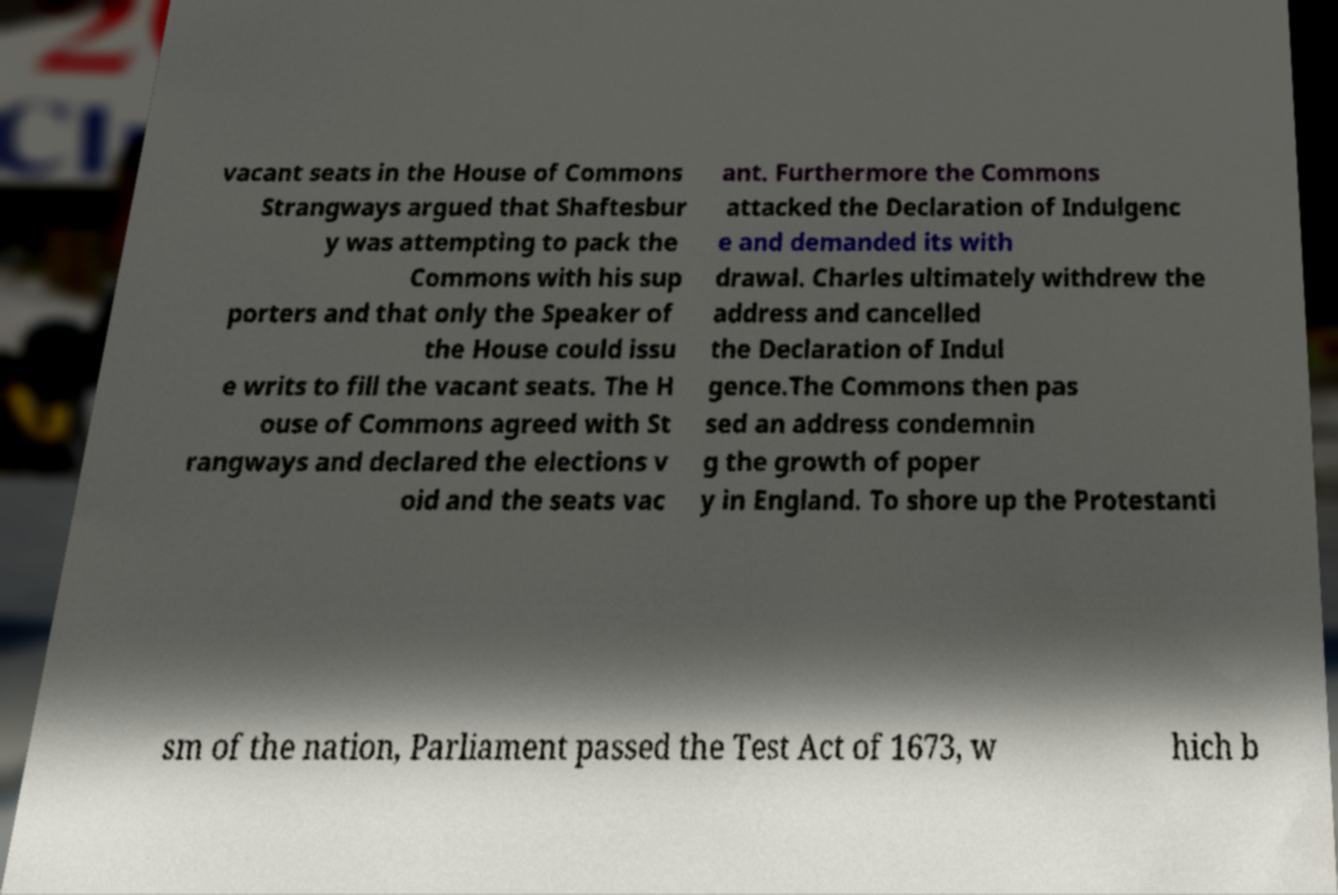What messages or text are displayed in this image? I need them in a readable, typed format. vacant seats in the House of Commons Strangways argued that Shaftesbur y was attempting to pack the Commons with his sup porters and that only the Speaker of the House could issu e writs to fill the vacant seats. The H ouse of Commons agreed with St rangways and declared the elections v oid and the seats vac ant. Furthermore the Commons attacked the Declaration of Indulgenc e and demanded its with drawal. Charles ultimately withdrew the address and cancelled the Declaration of Indul gence.The Commons then pas sed an address condemnin g the growth of poper y in England. To shore up the Protestanti sm of the nation, Parliament passed the Test Act of 1673, w hich b 